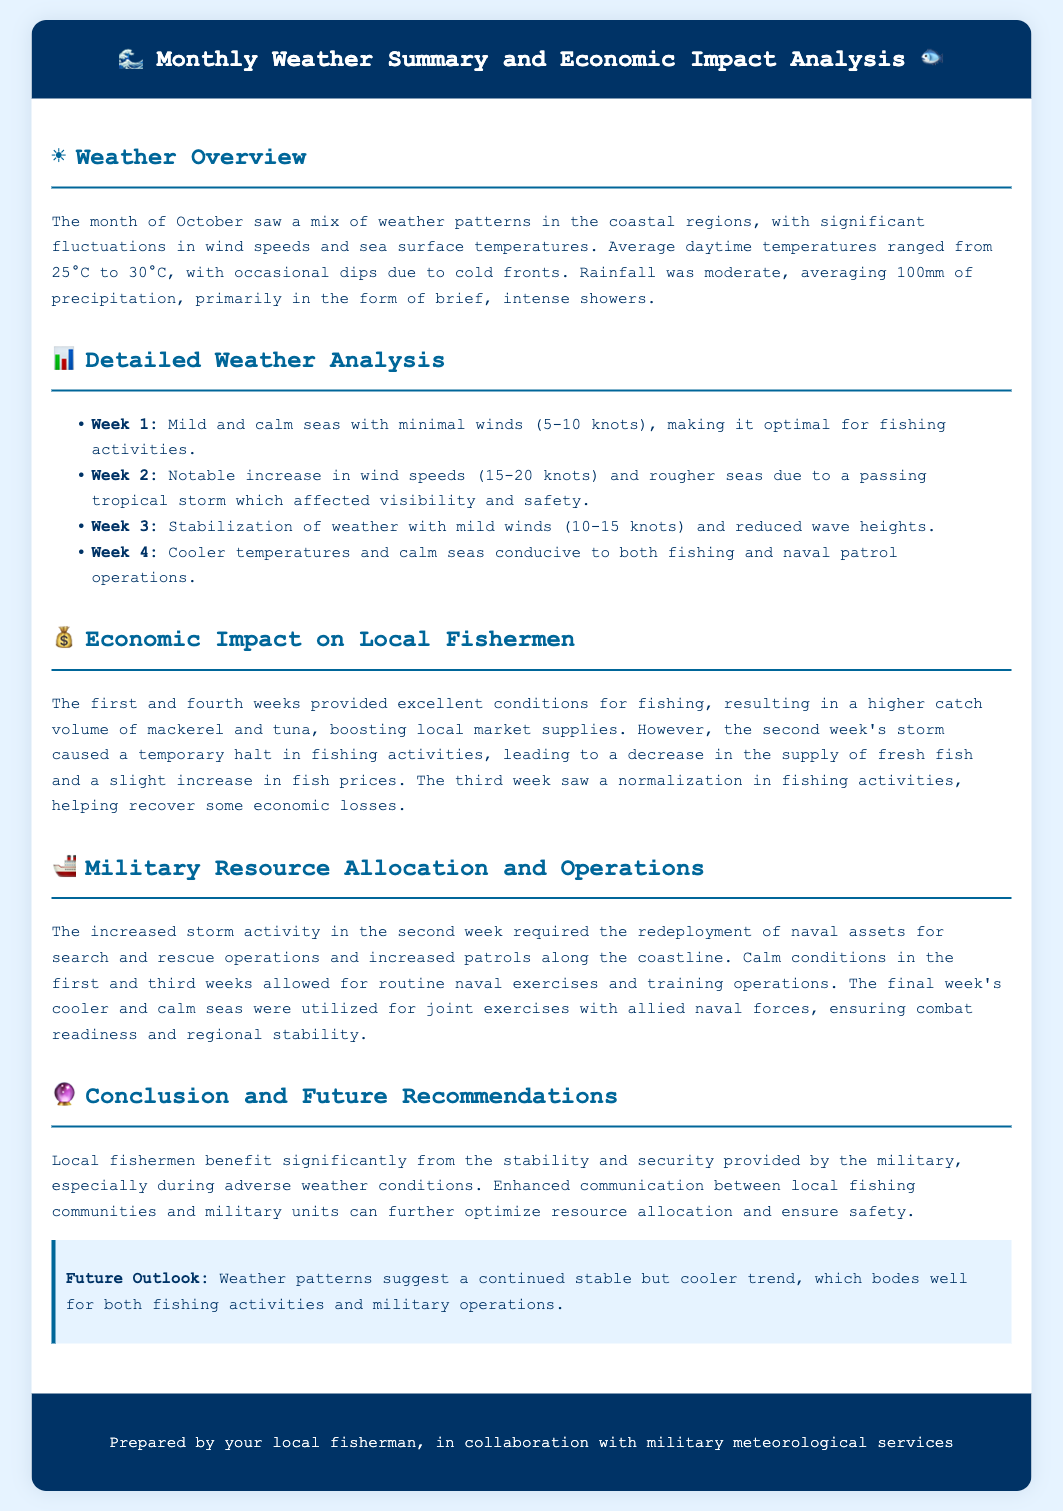What was the average daily temperature range in October? The document states that average daytime temperatures ranged from 25°C to 30°C.
Answer: 25°C to 30°C Which week experienced a tropical storm? The second week is noted for a notable increase in wind speeds and rougher seas due to a passing tropical storm.
Answer: Week 2 What type of fish saw a higher catch volume in the first week? The economic impact section mentions that mackerel and tuna were boosted in local market supplies during the first week.
Answer: Mackerel and tuna What operations took place during the final week of October? The last week allowed for joint exercises with allied naval forces ensuring combat readiness and regional stability.
Answer: Joint exercises with allied naval forces How much precipitation was recorded on average during October? The document specifies that rainfall was moderate, averaging 100mm of precipitation.
Answer: 100mm 